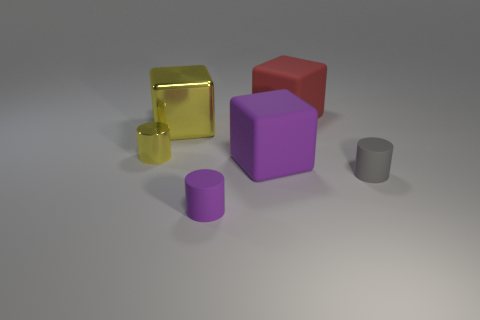Add 4 red matte objects. How many objects exist? 10 Subtract all red matte blocks. Subtract all purple objects. How many objects are left? 3 Add 4 small cylinders. How many small cylinders are left? 7 Add 3 yellow metal things. How many yellow metal things exist? 5 Subtract 0 blue cylinders. How many objects are left? 6 